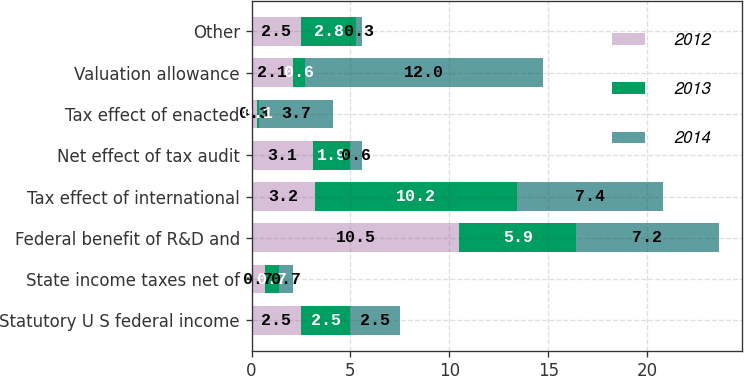Convert chart to OTSL. <chart><loc_0><loc_0><loc_500><loc_500><stacked_bar_chart><ecel><fcel>Statutory U S federal income<fcel>State income taxes net of<fcel>Federal benefit of R&D and<fcel>Tax effect of international<fcel>Net effect of tax audit<fcel>Tax effect of enacted<fcel>Valuation allowance<fcel>Other<nl><fcel>2012<fcel>2.5<fcel>0.7<fcel>10.5<fcel>3.2<fcel>3.1<fcel>0.3<fcel>2.1<fcel>2.5<nl><fcel>2013<fcel>2.5<fcel>0.7<fcel>5.9<fcel>10.2<fcel>1.9<fcel>0.1<fcel>0.6<fcel>2.8<nl><fcel>2014<fcel>2.5<fcel>0.7<fcel>7.2<fcel>7.4<fcel>0.6<fcel>3.7<fcel>12<fcel>0.3<nl></chart> 